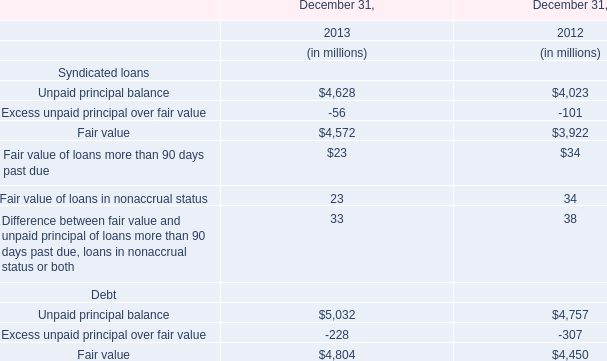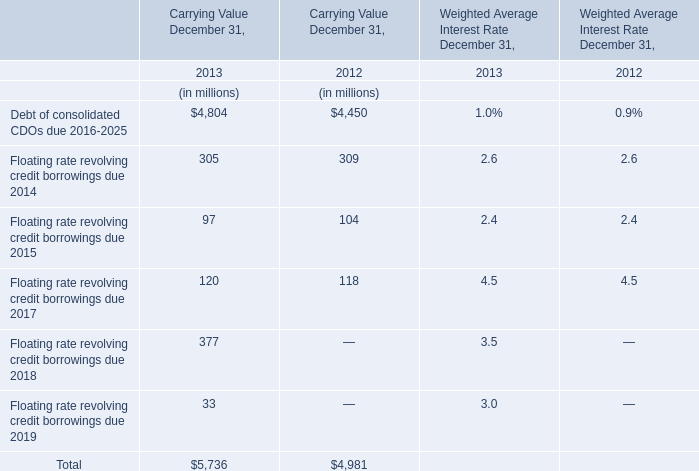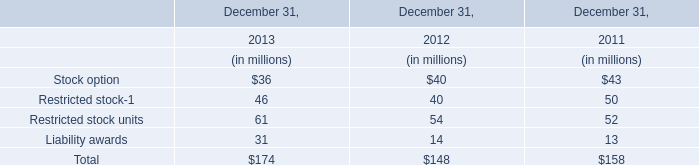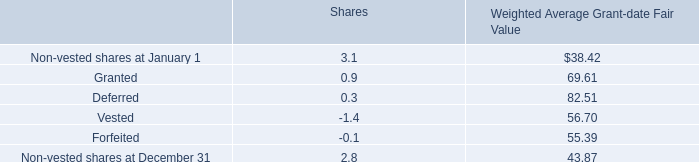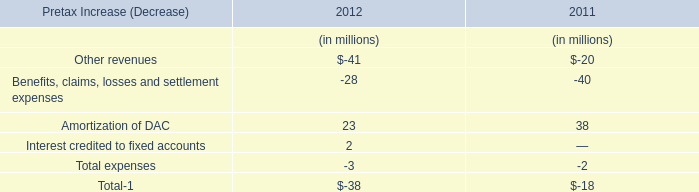In the year with largest amount of Unpaid principal balance of Syndicated loans, what's the increasing rate of Unpaid principal balance of Debt? 
Computations: ((5032 - 4757) / 4757)
Answer: 0.05781. 